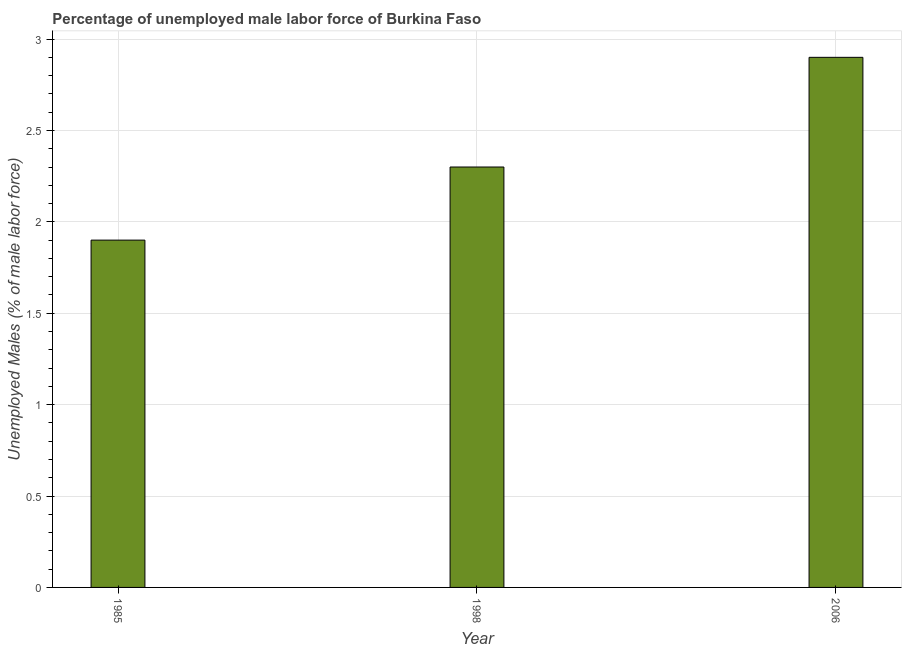Does the graph contain grids?
Provide a short and direct response. Yes. What is the title of the graph?
Offer a terse response. Percentage of unemployed male labor force of Burkina Faso. What is the label or title of the Y-axis?
Provide a short and direct response. Unemployed Males (% of male labor force). What is the total unemployed male labour force in 1998?
Keep it short and to the point. 2.3. Across all years, what is the maximum total unemployed male labour force?
Make the answer very short. 2.9. Across all years, what is the minimum total unemployed male labour force?
Ensure brevity in your answer.  1.9. In which year was the total unemployed male labour force maximum?
Give a very brief answer. 2006. In which year was the total unemployed male labour force minimum?
Ensure brevity in your answer.  1985. What is the sum of the total unemployed male labour force?
Your answer should be very brief. 7.1. What is the difference between the total unemployed male labour force in 1985 and 2006?
Your response must be concise. -1. What is the average total unemployed male labour force per year?
Make the answer very short. 2.37. What is the median total unemployed male labour force?
Provide a short and direct response. 2.3. In how many years, is the total unemployed male labour force greater than 1.7 %?
Provide a short and direct response. 3. Do a majority of the years between 1998 and 1985 (inclusive) have total unemployed male labour force greater than 1.7 %?
Provide a short and direct response. No. What is the ratio of the total unemployed male labour force in 1985 to that in 1998?
Your answer should be compact. 0.83. Is the sum of the total unemployed male labour force in 1985 and 1998 greater than the maximum total unemployed male labour force across all years?
Your answer should be very brief. Yes. What is the difference between the highest and the lowest total unemployed male labour force?
Make the answer very short. 1. In how many years, is the total unemployed male labour force greater than the average total unemployed male labour force taken over all years?
Your answer should be very brief. 1. What is the difference between two consecutive major ticks on the Y-axis?
Your answer should be compact. 0.5. Are the values on the major ticks of Y-axis written in scientific E-notation?
Provide a short and direct response. No. What is the Unemployed Males (% of male labor force) of 1985?
Offer a very short reply. 1.9. What is the Unemployed Males (% of male labor force) in 1998?
Make the answer very short. 2.3. What is the Unemployed Males (% of male labor force) in 2006?
Your answer should be compact. 2.9. What is the difference between the Unemployed Males (% of male labor force) in 1985 and 2006?
Keep it short and to the point. -1. What is the difference between the Unemployed Males (% of male labor force) in 1998 and 2006?
Give a very brief answer. -0.6. What is the ratio of the Unemployed Males (% of male labor force) in 1985 to that in 1998?
Offer a terse response. 0.83. What is the ratio of the Unemployed Males (% of male labor force) in 1985 to that in 2006?
Ensure brevity in your answer.  0.66. What is the ratio of the Unemployed Males (% of male labor force) in 1998 to that in 2006?
Keep it short and to the point. 0.79. 